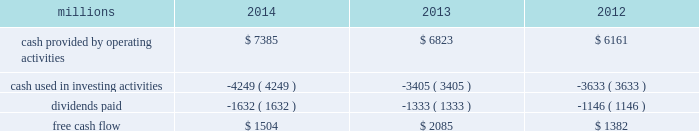Generate cash without additional external financings .
Free cash flow should be considered in addition to , rather than as a substitute for , cash provided by operating activities .
The table reconciles cash provided by operating activities ( gaap measure ) to free cash flow ( non-gaap measure ) : millions 2014 2013 2012 .
2015 outlook f0b7 safety 2013 operating a safe railroad benefits all our constituents : our employees , customers , shareholders and the communities we serve .
We will continue using a multi-faceted approach to safety , utilizing technology , risk assessment , quality control , training and employee engagement , and targeted capital investments .
We will continue using and expanding the deployment of total safety culture and courage to care throughout our operations , which allows us to identify and implement best practices for employee and operational safety .
We will continue our efforts to increase detection of rail defects ; improve or close crossings ; and educate the public and law enforcement agencies about crossing safety through a combination of our own programs ( including risk assessment strategies ) , industry programs and local community activities across our network .
F0b7 network operations 2013 in 2015 , we will continue to add resources to support growth , improve service , and replenish our surge capability .
F0b7 fuel prices 2013 with the dramatic drop in fuel prices at the end of 2014 , there is even more uncertainty around the projections of fuel prices .
We again could see volatile fuel prices during the year , as they are sensitive to global and u.s .
Domestic demand , refining capacity , geopolitical events , weather conditions and other factors .
As prices fluctuate there will be a timing impact on earnings , as our fuel surcharge programs trail fluctuations in fuel price by approximately two months .
Lower fuel prices could have a positive impact on the economy by increasing consumer discretionary spending that potentially could increase demand for various consumer products that we transport .
Alternatively , lower fuel prices will likely have a negative impact on other commodities such as coal , frac sand and crude oil shipments .
F0b7 capital plan 2013 in 2015 , we expect our capital plan to be approximately $ 4.3 billion , including expenditures for ptc and 218 locomotives .
The capital plan may be revised if business conditions warrant or if new laws or regulations affect our ability to generate sufficient returns on these investments .
( see further discussion in this item 7 under liquidity and capital resources 2013 capital plan. ) f0b7 financial expectations 2013 we expect the overall u.s .
Economy to continue to improve at a moderate pace .
One of the biggest uncertainties is the outlook for energy markets , which will bring both challenges and opportunities .
On balance , we expect to see positive volume growth for 2015 versus the prior year .
In the current environment , we expect continued margin improvement driven by continued pricing opportunities , ongoing productivity initiatives and the ability to leverage our resources as we improve the fluidity of our network. .
If operating cash flow increases in 2015 at the same pace as in 2014 , what would the expected amount be? 
Computations: (((7385 / 6823) * 6823) * 1000000)
Answer: 7385000000.0. 